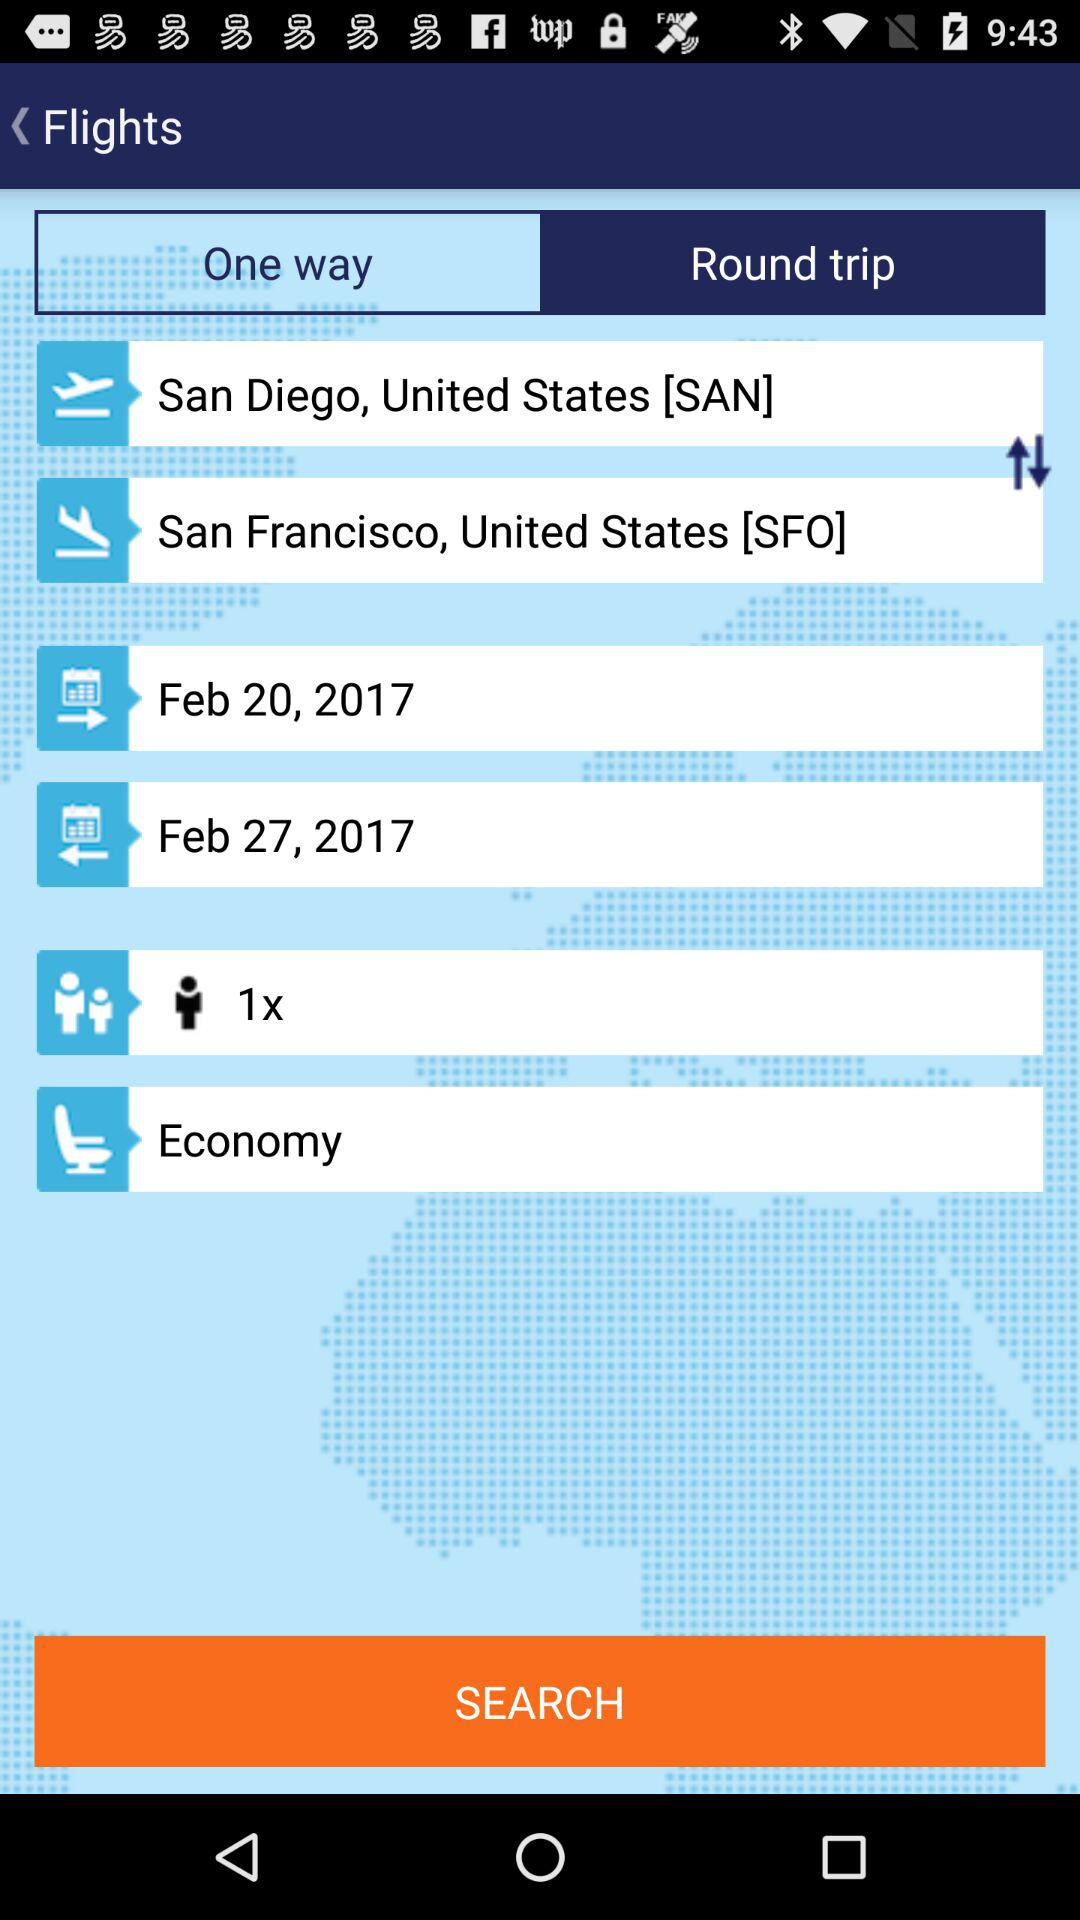What is the end location? The end location is San Francisco, United States [SFO]. 